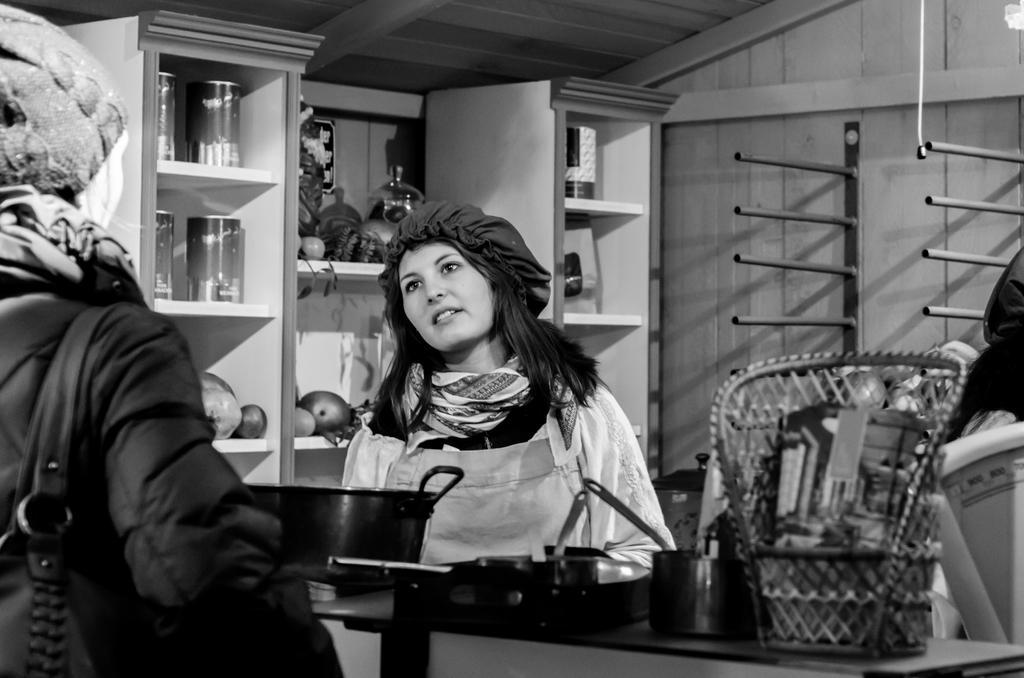In one or two sentences, can you explain what this image depicts? In this black and white image, we can see persons wearing clothes. There is a table at the bottom of the image contains dishes and basket. There are metal stands on the right side of the image. There is a cupboard in the middle of the image contains vegetables and tins. 